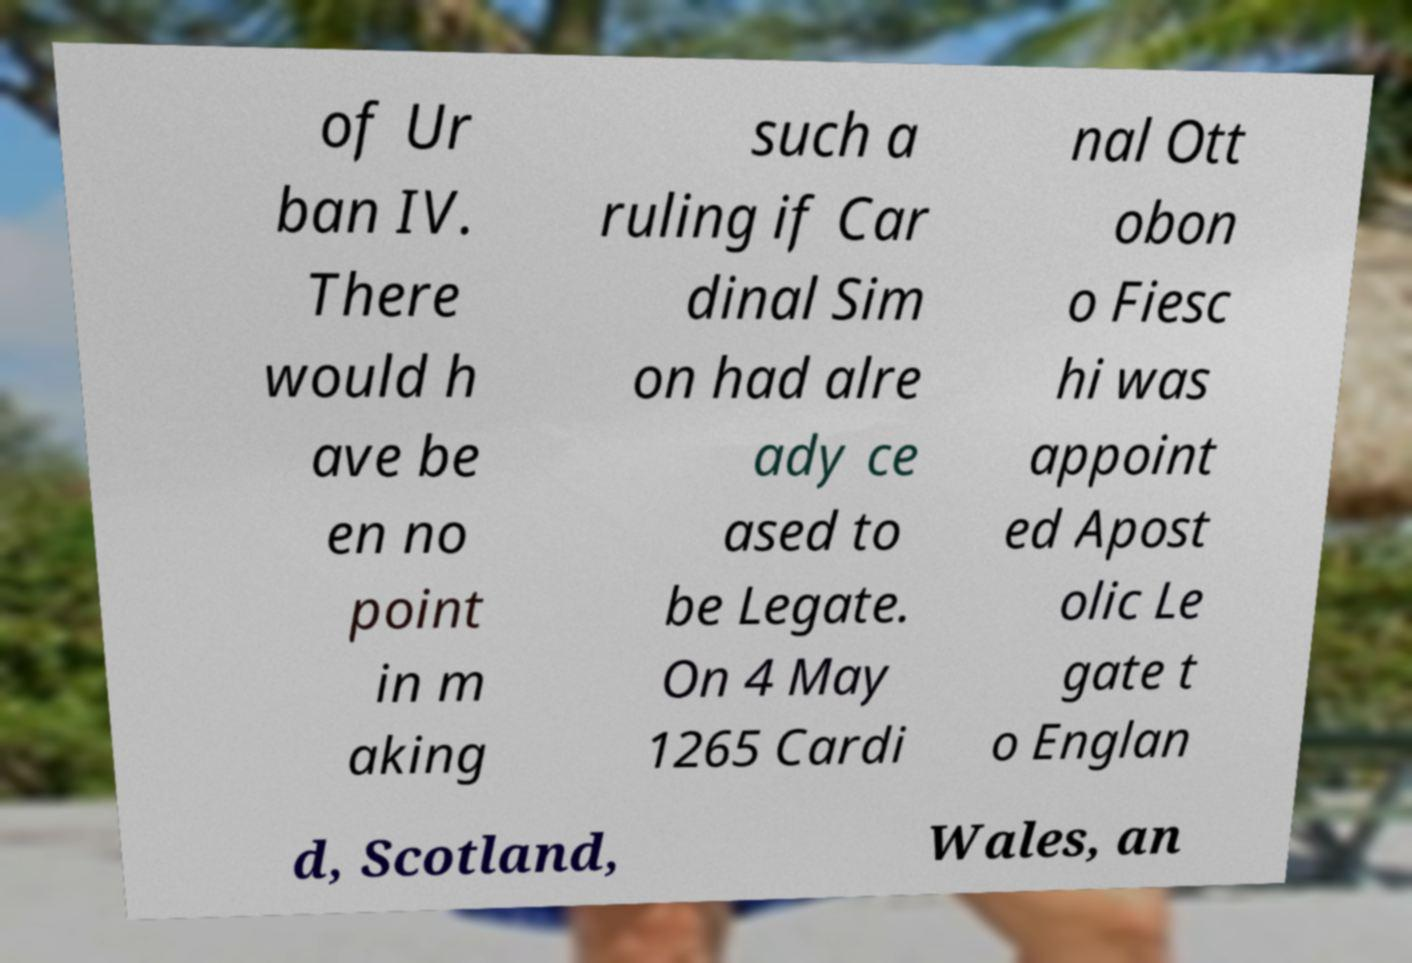Can you accurately transcribe the text from the provided image for me? of Ur ban IV. There would h ave be en no point in m aking such a ruling if Car dinal Sim on had alre ady ce ased to be Legate. On 4 May 1265 Cardi nal Ott obon o Fiesc hi was appoint ed Apost olic Le gate t o Englan d, Scotland, Wales, an 